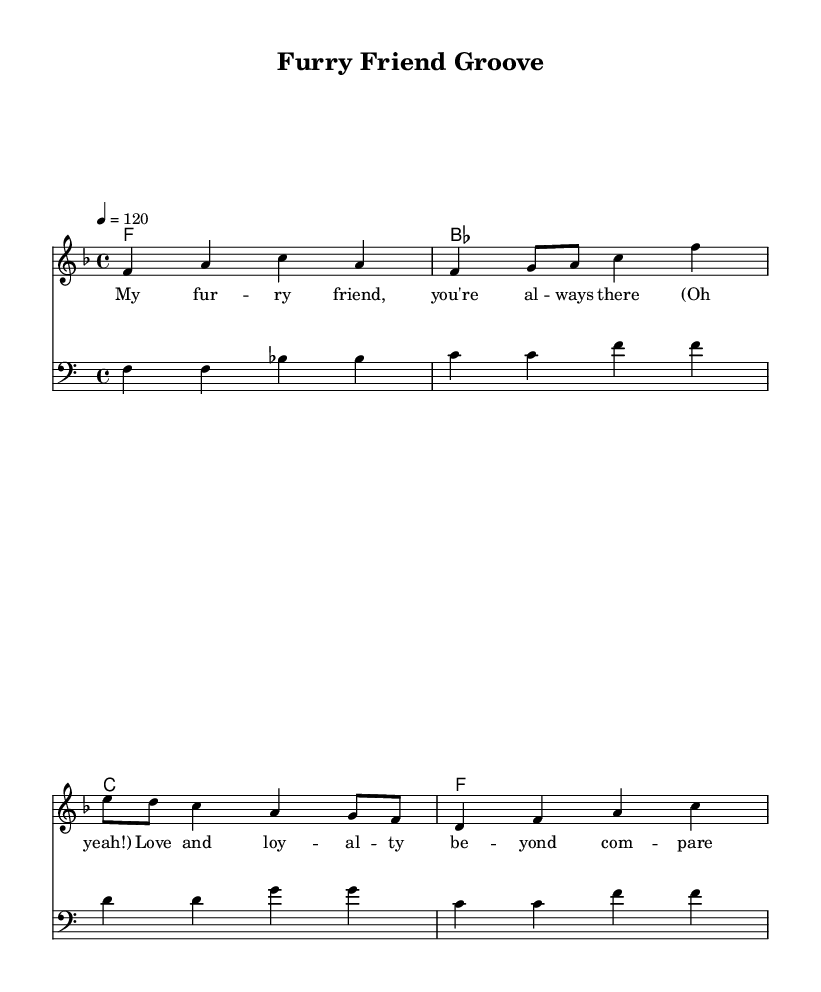What is the key signature of this music? The key signature is F major, which has one flat (B flat). This can be identified from the key signature indicated at the beginning of the staff where the note B is marked flat.
Answer: F major What is the time signature of this piece? The time signature is 4/4, which indicates that there are four beats in each measure and the quarter note receives one beat. This can be seen where the time signature is displayed at the start of the score.
Answer: 4/4 What is the tempo marking for this piece? The tempo marking is 120 beats per minute. This is noted at the beginning of the score, which indicates the speed at which the piece should be played.
Answer: 120 How many measures are in the melody? The melody consists of four measures, which can be counted by looking at the bar lines that separate each section of notes in the melody.
Answer: 4 What is the specific genre characteristic reflected in the title? The title "Furry Friend Groove" reflects the upbeat and celebratory nature typical of soul music, highlighting the joy and bond between humans and their pets, which is a common thematic element in the genre.
Answer: Upbeat celebration What type of lyrics are used in this piece? The lyrics express affection and loyalty, commonly found in soul music that often emphasizes themes of love and companionship. The lyrics show a deep connection that reflects the bond between pets and their owners.
Answer: Affectionate loyalty 